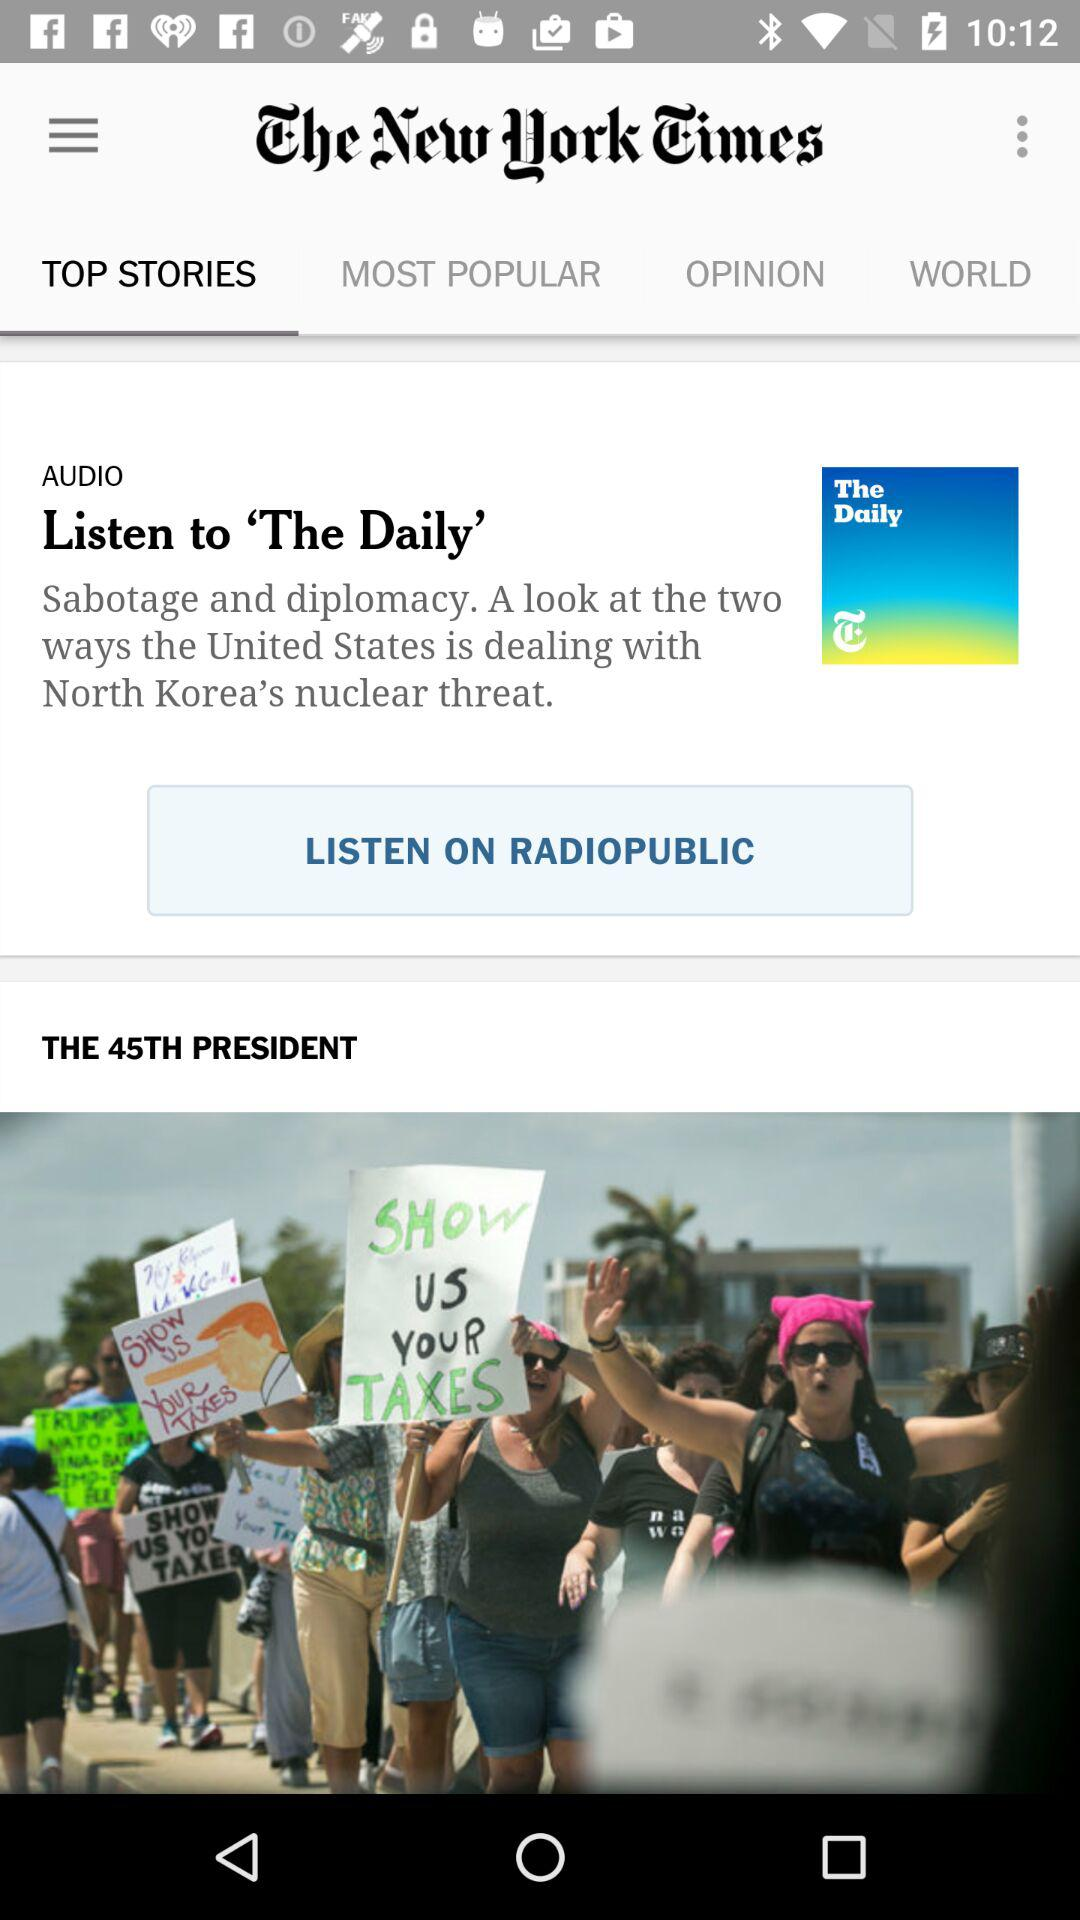Which tab is selected? The selected tab is "TOP STORIES". 